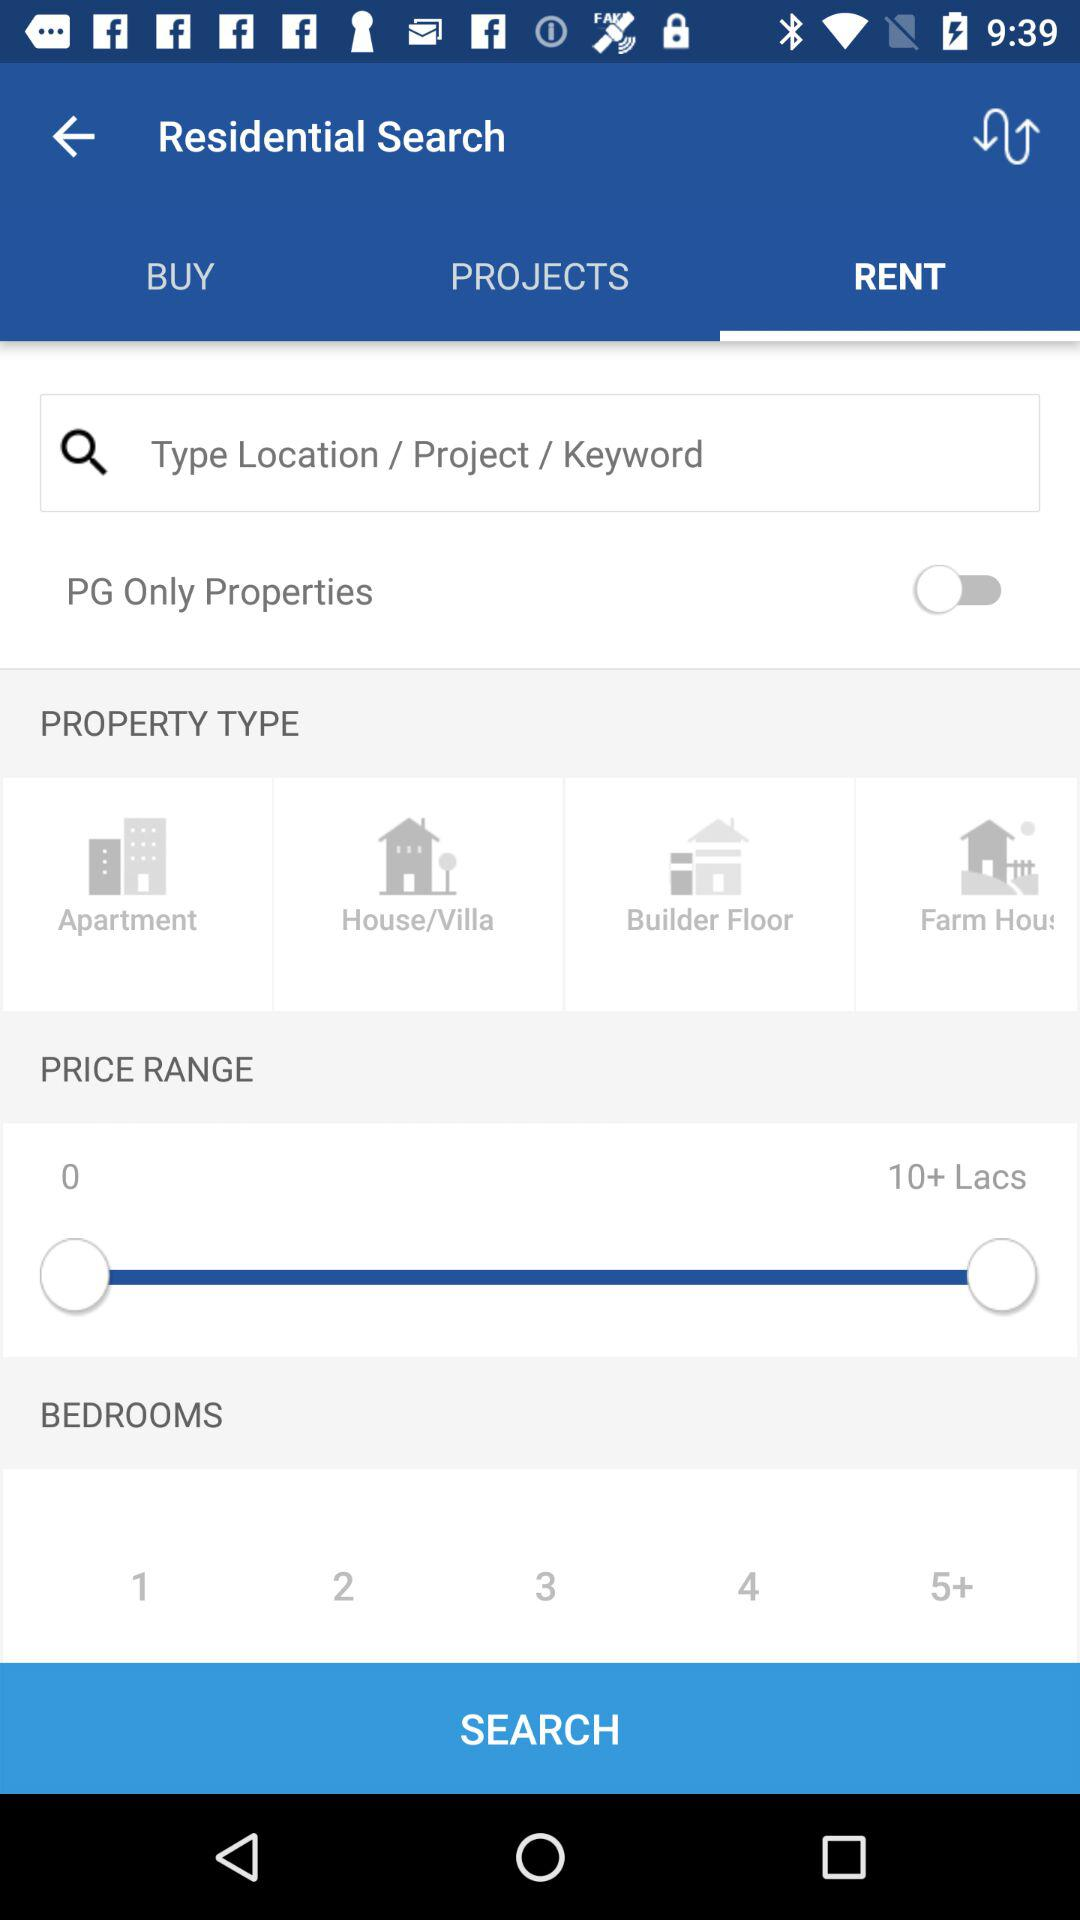What is the status of PG Only Properties? The status is off. 